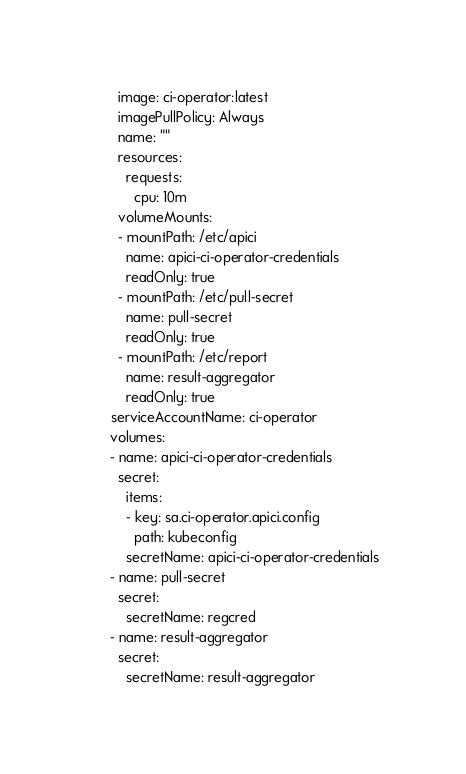Convert code to text. <code><loc_0><loc_0><loc_500><loc_500><_YAML_>        image: ci-operator:latest
        imagePullPolicy: Always
        name: ""
        resources:
          requests:
            cpu: 10m
        volumeMounts:
        - mountPath: /etc/apici
          name: apici-ci-operator-credentials
          readOnly: true
        - mountPath: /etc/pull-secret
          name: pull-secret
          readOnly: true
        - mountPath: /etc/report
          name: result-aggregator
          readOnly: true
      serviceAccountName: ci-operator
      volumes:
      - name: apici-ci-operator-credentials
        secret:
          items:
          - key: sa.ci-operator.apici.config
            path: kubeconfig
          secretName: apici-ci-operator-credentials
      - name: pull-secret
        secret:
          secretName: regcred
      - name: result-aggregator
        secret:
          secretName: result-aggregator
</code> 